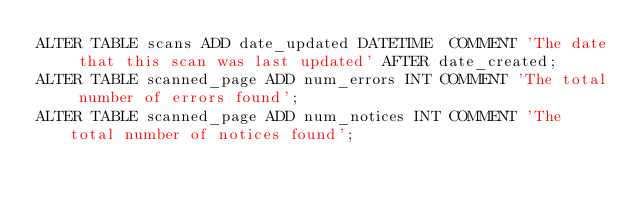<code> <loc_0><loc_0><loc_500><loc_500><_SQL_>ALTER TABLE scans ADD date_updated DATETIME  COMMENT 'The date that this scan was last updated' AFTER date_created;
ALTER TABLE scanned_page ADD num_errors INT COMMENT 'The total number of errors found';
ALTER TABLE scanned_page ADD num_notices INT COMMENT 'The total number of notices found';</code> 